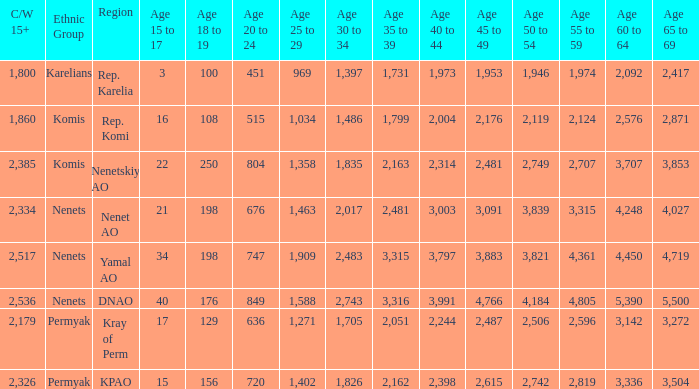What is the mean 55 to 59 when the C/W 15+ is greater than 2,385, and the 30 to 34 is 2,483, and the 35 to 39 is greater than 3,315? None. 